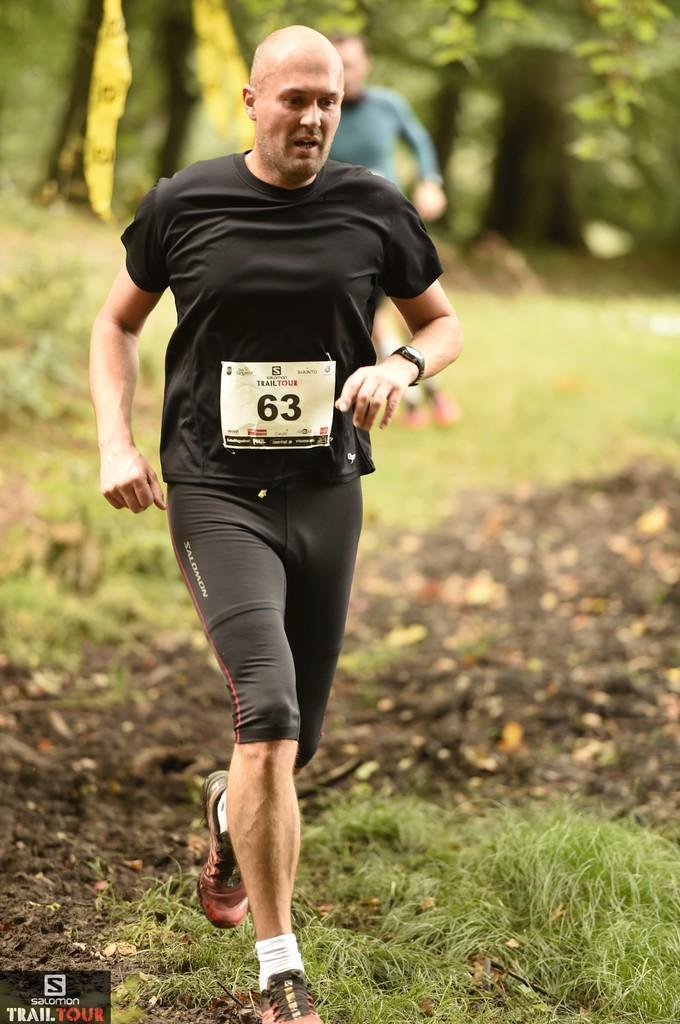How many people are in the image? There are two persons in the image. Where are the persons located in the image? The persons are on the grass. What can be seen in the background of the image? There are trees in the background of the image. What might be the location of the image? The image is likely taken in a park. What time of day is the image likely taken? The image is likely taken during the day. What type of pizzas are the persons eating in the image? There are no pizzas present in the image. What are the persons talking about in the image? The conversation does not provide any information about what the persons might be talking about. 